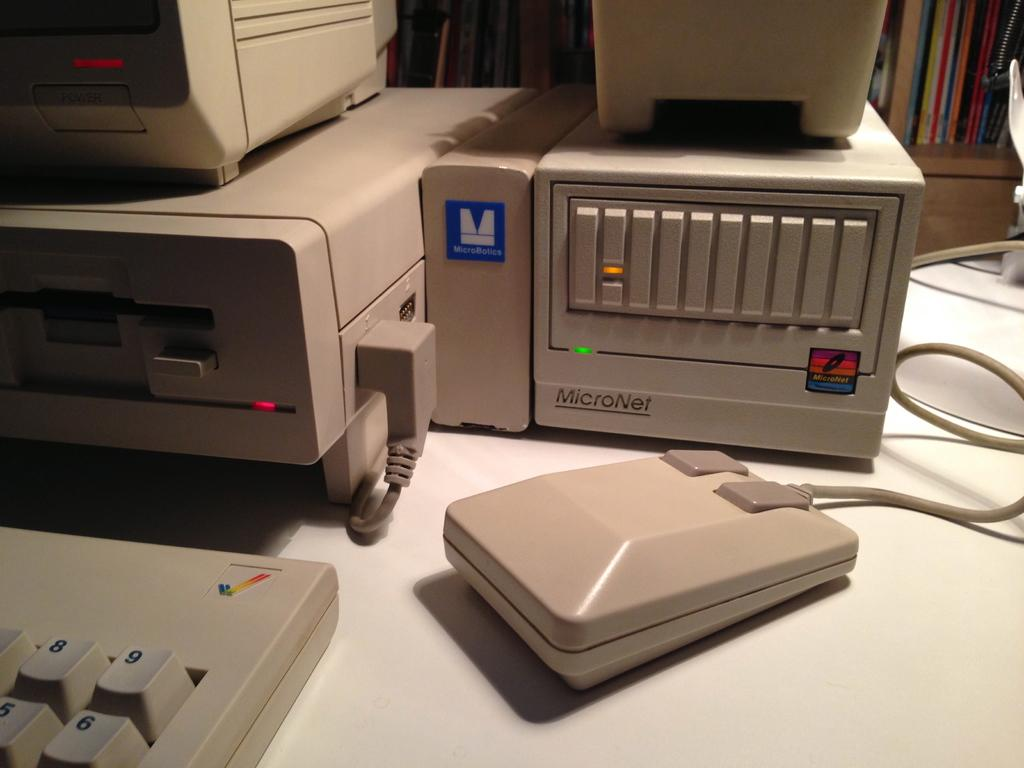What objects are on the table in the image? There are electronic devices on a table in the image. Can you describe one of the electronic devices in more detail? Yes, a keyboard is on the table. What can be seen in the background of the image? There are books on racks in the background. How does the worm contribute to the comparison of the electronic devices in the image? There is no worm present in the image, and therefore it cannot contribute to any comparison of the electronic devices. 